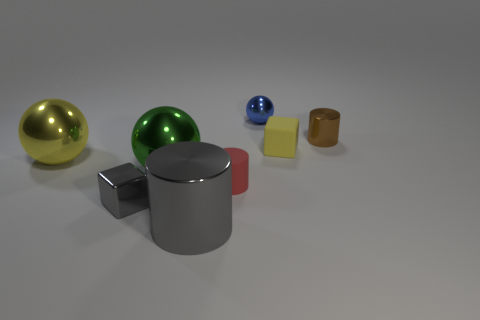There is a block that is the same color as the large metallic cylinder; what is its material?
Offer a terse response. Metal. How many small things are to the left of the matte block and behind the small yellow matte object?
Offer a terse response. 1. Does the gray shiny cylinder have the same size as the block that is in front of the big green ball?
Keep it short and to the point. No. There is a cylinder on the right side of the yellow thing that is on the right side of the green metal sphere; is there a yellow cube that is to the left of it?
Keep it short and to the point. Yes. What is the material of the tiny cube on the right side of the rubber object that is in front of the tiny yellow cube?
Offer a very short reply. Rubber. The large object that is both to the right of the shiny block and behind the red rubber thing is made of what material?
Offer a terse response. Metal. Is there a purple shiny thing of the same shape as the tiny yellow thing?
Offer a terse response. No. There is a cube to the left of the blue object; are there any metal blocks in front of it?
Provide a short and direct response. No. What number of tiny brown balls are the same material as the tiny brown cylinder?
Make the answer very short. 0. Are any blue rubber balls visible?
Provide a short and direct response. No. 